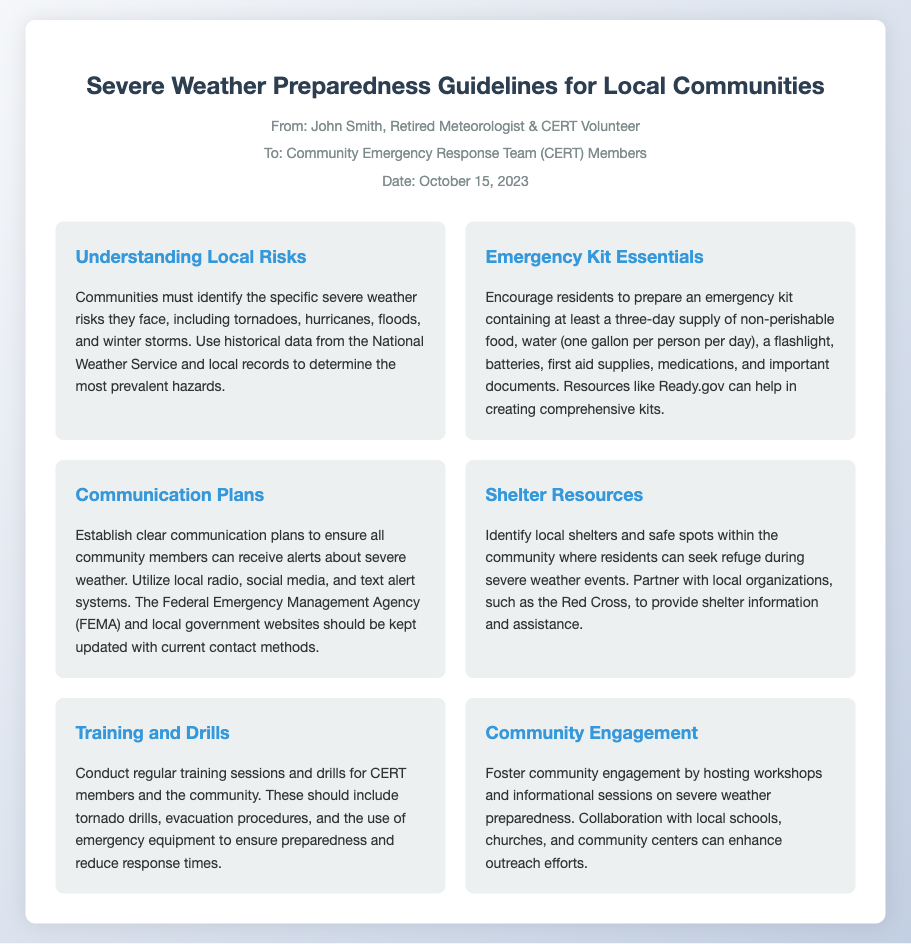What is the title of the memo? The title can be found at the top of the document in bold letters under the header section.
Answer: Severe Weather Preparedness Guidelines for Local Communities Who is the author of the memo? The author is mentioned in the header section, listed right after the title.
Answer: John Smith What date was the memo issued? The date can be found in the meta section of the header.
Answer: October 15, 2023 What is the first guideline in the document? The first guideline is indicated as a heading in the guideline section of the memo.
Answer: Understanding Local Risks How many days' supply of water is recommended for the emergency kit? The recommendation for water supply is given in the Emergency Kit Essentials section.
Answer: One gallon per person per day Which organization is mentioned as a partner for shelter resources? The partner organization is clearly named in the Shelter Resources section of the guidelines.
Answer: Red Cross What type of events are encouraged for community engagement? Community engagement activities are described in the respective guideline and touch upon various initiatives.
Answer: Workshops and informational sessions What is the main purpose of the training and drills? The purpose of the training and drills is explained in the Training and Drills guideline.
Answer: To ensure preparedness and reduce response times Which government agency's website should be kept updated for communication plans? This detail is found in the Communication Plans section of the document.
Answer: FEMA 